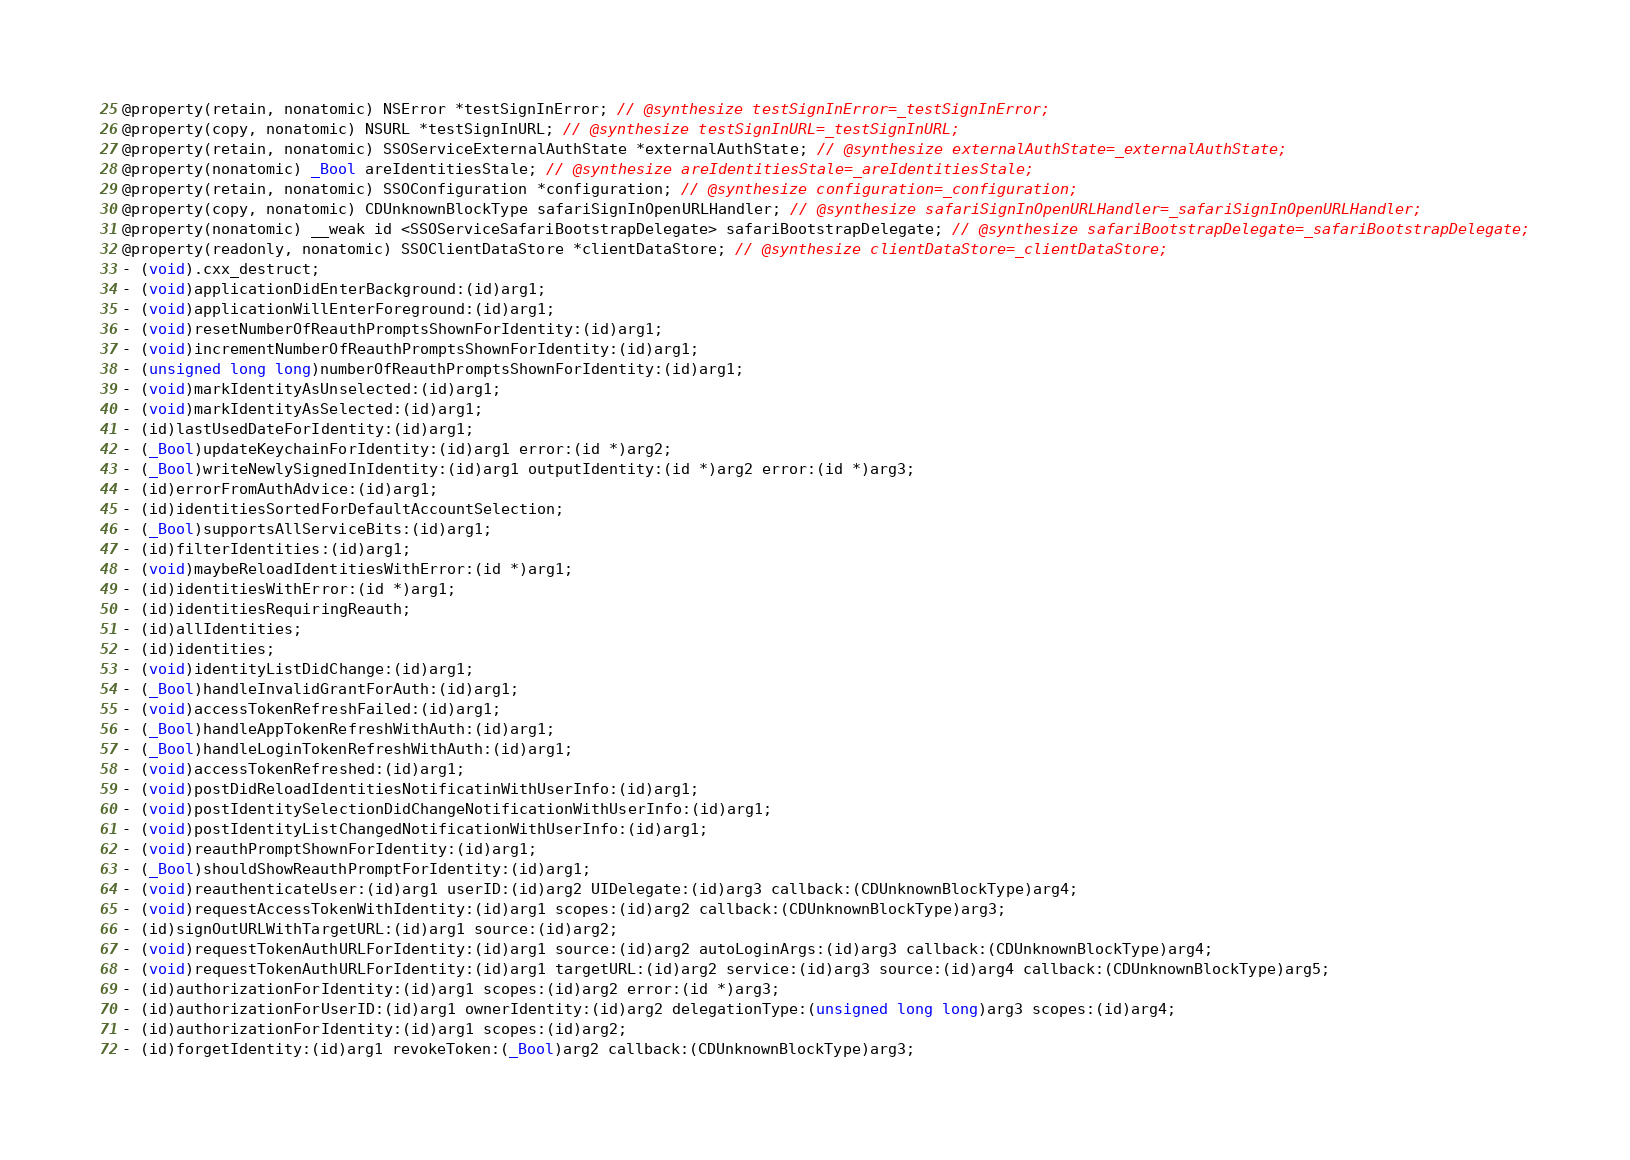Convert code to text. <code><loc_0><loc_0><loc_500><loc_500><_C_>@property(retain, nonatomic) NSError *testSignInError; // @synthesize testSignInError=_testSignInError;
@property(copy, nonatomic) NSURL *testSignInURL; // @synthesize testSignInURL=_testSignInURL;
@property(retain, nonatomic) SSOServiceExternalAuthState *externalAuthState; // @synthesize externalAuthState=_externalAuthState;
@property(nonatomic) _Bool areIdentitiesStale; // @synthesize areIdentitiesStale=_areIdentitiesStale;
@property(retain, nonatomic) SSOConfiguration *configuration; // @synthesize configuration=_configuration;
@property(copy, nonatomic) CDUnknownBlockType safariSignInOpenURLHandler; // @synthesize safariSignInOpenURLHandler=_safariSignInOpenURLHandler;
@property(nonatomic) __weak id <SSOServiceSafariBootstrapDelegate> safariBootstrapDelegate; // @synthesize safariBootstrapDelegate=_safariBootstrapDelegate;
@property(readonly, nonatomic) SSOClientDataStore *clientDataStore; // @synthesize clientDataStore=_clientDataStore;
- (void).cxx_destruct;
- (void)applicationDidEnterBackground:(id)arg1;
- (void)applicationWillEnterForeground:(id)arg1;
- (void)resetNumberOfReauthPromptsShownForIdentity:(id)arg1;
- (void)incrementNumberOfReauthPromptsShownForIdentity:(id)arg1;
- (unsigned long long)numberOfReauthPromptsShownForIdentity:(id)arg1;
- (void)markIdentityAsUnselected:(id)arg1;
- (void)markIdentityAsSelected:(id)arg1;
- (id)lastUsedDateForIdentity:(id)arg1;
- (_Bool)updateKeychainForIdentity:(id)arg1 error:(id *)arg2;
- (_Bool)writeNewlySignedInIdentity:(id)arg1 outputIdentity:(id *)arg2 error:(id *)arg3;
- (id)errorFromAuthAdvice:(id)arg1;
- (id)identitiesSortedForDefaultAccountSelection;
- (_Bool)supportsAllServiceBits:(id)arg1;
- (id)filterIdentities:(id)arg1;
- (void)maybeReloadIdentitiesWithError:(id *)arg1;
- (id)identitiesWithError:(id *)arg1;
- (id)identitiesRequiringReauth;
- (id)allIdentities;
- (id)identities;
- (void)identityListDidChange:(id)arg1;
- (_Bool)handleInvalidGrantForAuth:(id)arg1;
- (void)accessTokenRefreshFailed:(id)arg1;
- (_Bool)handleAppTokenRefreshWithAuth:(id)arg1;
- (_Bool)handleLoginTokenRefreshWithAuth:(id)arg1;
- (void)accessTokenRefreshed:(id)arg1;
- (void)postDidReloadIdentitiesNotificatinWithUserInfo:(id)arg1;
- (void)postIdentitySelectionDidChangeNotificationWithUserInfo:(id)arg1;
- (void)postIdentityListChangedNotificationWithUserInfo:(id)arg1;
- (void)reauthPromptShownForIdentity:(id)arg1;
- (_Bool)shouldShowReauthPromptForIdentity:(id)arg1;
- (void)reauthenticateUser:(id)arg1 userID:(id)arg2 UIDelegate:(id)arg3 callback:(CDUnknownBlockType)arg4;
- (void)requestAccessTokenWithIdentity:(id)arg1 scopes:(id)arg2 callback:(CDUnknownBlockType)arg3;
- (id)signOutURLWithTargetURL:(id)arg1 source:(id)arg2;
- (void)requestTokenAuthURLForIdentity:(id)arg1 source:(id)arg2 autoLoginArgs:(id)arg3 callback:(CDUnknownBlockType)arg4;
- (void)requestTokenAuthURLForIdentity:(id)arg1 targetURL:(id)arg2 service:(id)arg3 source:(id)arg4 callback:(CDUnknownBlockType)arg5;
- (id)authorizationForIdentity:(id)arg1 scopes:(id)arg2 error:(id *)arg3;
- (id)authorizationForUserID:(id)arg1 ownerIdentity:(id)arg2 delegationType:(unsigned long long)arg3 scopes:(id)arg4;
- (id)authorizationForIdentity:(id)arg1 scopes:(id)arg2;
- (id)forgetIdentity:(id)arg1 revokeToken:(_Bool)arg2 callback:(CDUnknownBlockType)arg3;</code> 